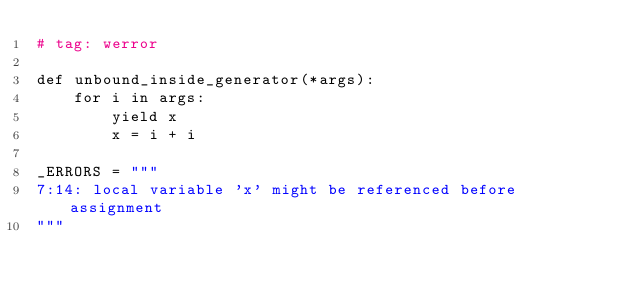Convert code to text. <code><loc_0><loc_0><loc_500><loc_500><_Cython_># tag: werror

def unbound_inside_generator(*args):
    for i in args:
        yield x
        x = i + i

_ERRORS = """
7:14: local variable 'x' might be referenced before assignment
"""
</code> 